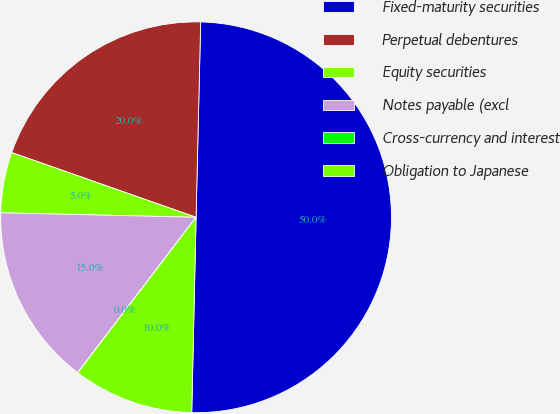<chart> <loc_0><loc_0><loc_500><loc_500><pie_chart><fcel>Fixed-maturity securities<fcel>Perpetual debentures<fcel>Equity securities<fcel>Notes payable (excl<fcel>Cross-currency and interest<fcel>Obligation to Japanese<nl><fcel>49.98%<fcel>20.0%<fcel>5.01%<fcel>15.0%<fcel>0.01%<fcel>10.0%<nl></chart> 